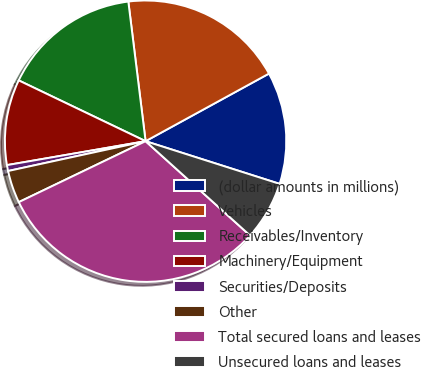Convert chart to OTSL. <chart><loc_0><loc_0><loc_500><loc_500><pie_chart><fcel>(dollar amounts in millions)<fcel>Vehicles<fcel>Receivables/Inventory<fcel>Machinery/Equipment<fcel>Securities/Deposits<fcel>Other<fcel>Total secured loans and leases<fcel>Unsecured loans and leases<nl><fcel>12.88%<fcel>18.98%<fcel>15.93%<fcel>9.83%<fcel>0.68%<fcel>3.73%<fcel>31.18%<fcel>6.78%<nl></chart> 